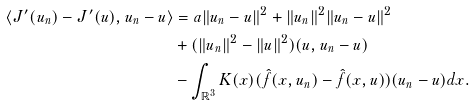Convert formula to latex. <formula><loc_0><loc_0><loc_500><loc_500>\langle J ^ { \prime } ( u _ { n } ) - J ^ { \prime } ( u ) , u _ { n } - u \rangle & = a \| u _ { n } - u \| ^ { 2 } + \| u _ { n } \| ^ { 2 } \| u _ { n } - u \| ^ { 2 } \\ & + ( \| u _ { n } \| ^ { 2 } - \| u \| ^ { 2 } ) ( u , u _ { n } - u ) \\ & - \int _ { \mathbb { R } ^ { 3 } } K ( x ) ( \hat { f } ( x , u _ { n } ) - \hat { f } ( x , u ) ) ( u _ { n } - u ) d x . \\</formula> 